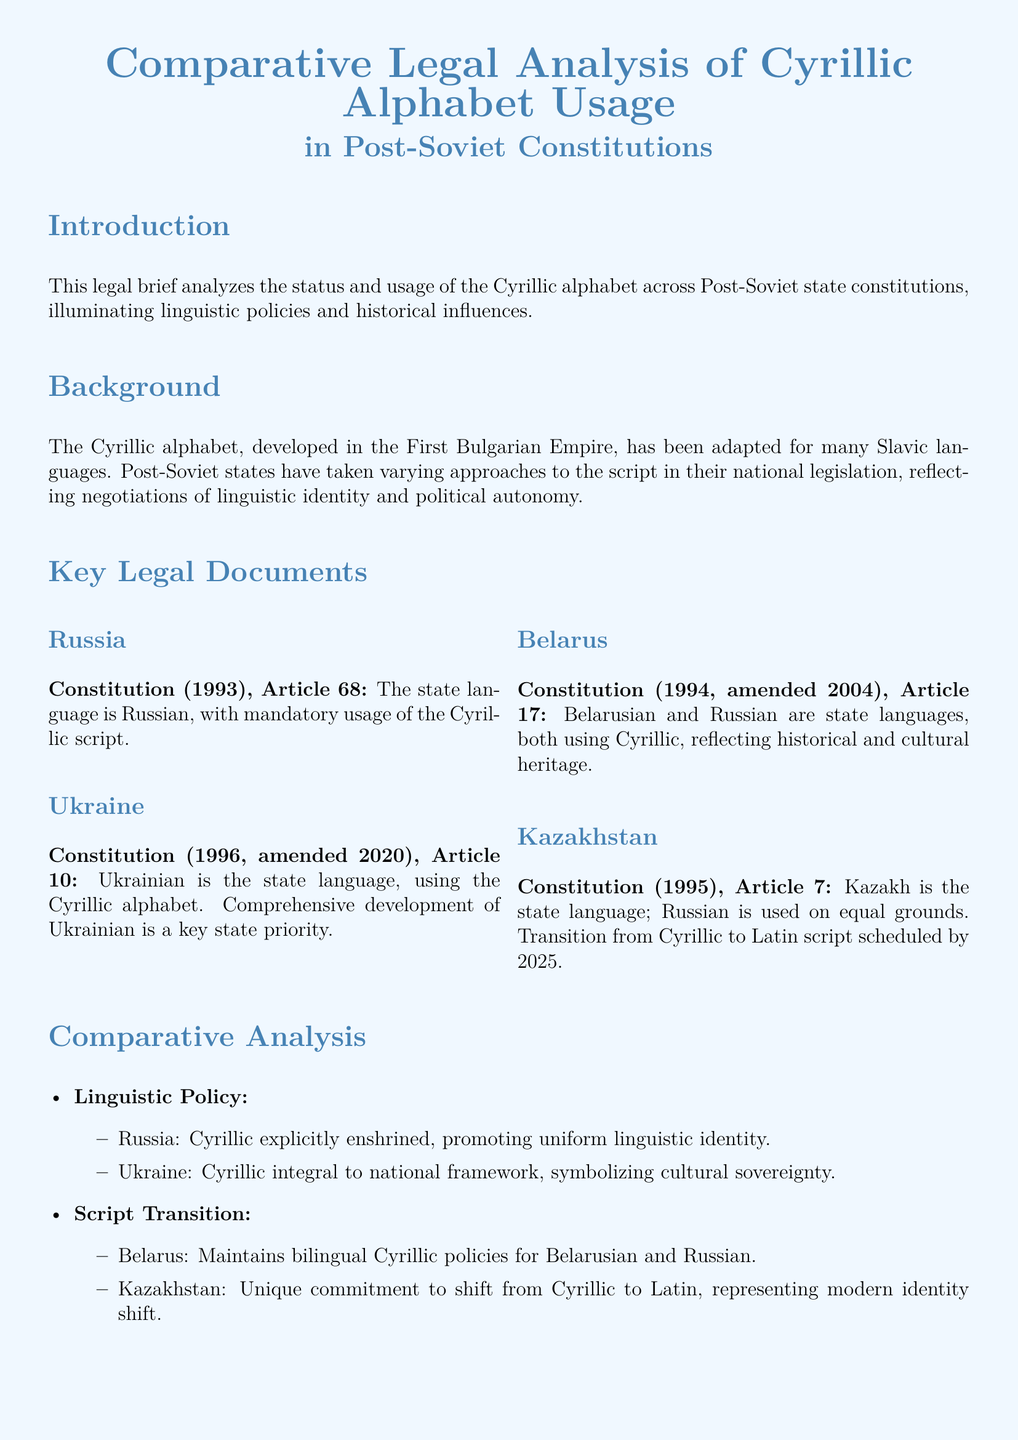What is the title of the legal brief? The title of the legal brief is given at the beginning and states the focus of the analysis on Cyrillic alphabet usage.
Answer: Comparative Legal Analysis of Cyrillic Alphabet Usage in Post-Soviet Constitutions What year was the Ukraine Constitution amended? The document specifies the amendment year of the Ukraine Constitution as part of its key legal documents.
Answer: 2020 Which script does the Kazakhstan Constitution plan to transition to? The document indicates Kazakhstan's commitment to shift to a new script as part of its linguistic policy.
Answer: Latin script What is the state language of Belarus? The key legal document for Belarus declares its primary languages and reflects its linguistic identity.
Answer: Belarusian and Russian Which country’s constitution explicitly enshrines Cyrillic? The comparison in linguistic policy highlights which country firmly maintains Cyrillic in its constitution.
Answer: Russia What key priority is stated in the Ukraine Constitution regarding the language? The document reveals a significant focus in Ukraine's constitutional policy regarding language development.
Answer: Comprehensive development of Ukrainian What notable linguistic transition is planned by Kazakhstan? The brief discusses Kazakhstan's linguistic policies, especially its upcoming change regarding script use.
Answer: Transition from Cyrillic to Latin script What does the comparative analysis indicate about Belarusian and Russian? The document highlights a specific bilingual policy maintained by Belarus, providing insight into its linguistic situation.
Answer: Maintains bilingual Cyrillic policies Which article of the Russian Constitution mentions the Cyrillic script? The legal brief lists several articles from different national constitutions that address the status of Cyrillic.
Answer: Article 68 